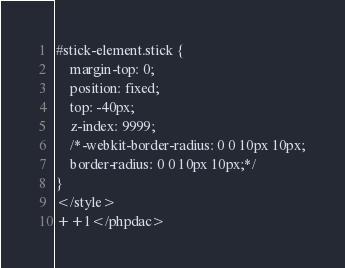Convert code to text. <code><loc_0><loc_0><loc_500><loc_500><_PHP_>#stick-element.stick {
    margin-top: 0;
    position: fixed;
    top: -40px;
    z-index: 9999;
    /*-webkit-border-radius: 0 0 10px 10px;
    border-radius: 0 0 10px 10px;*/
}
</style>
++1</phpdac>
</code> 